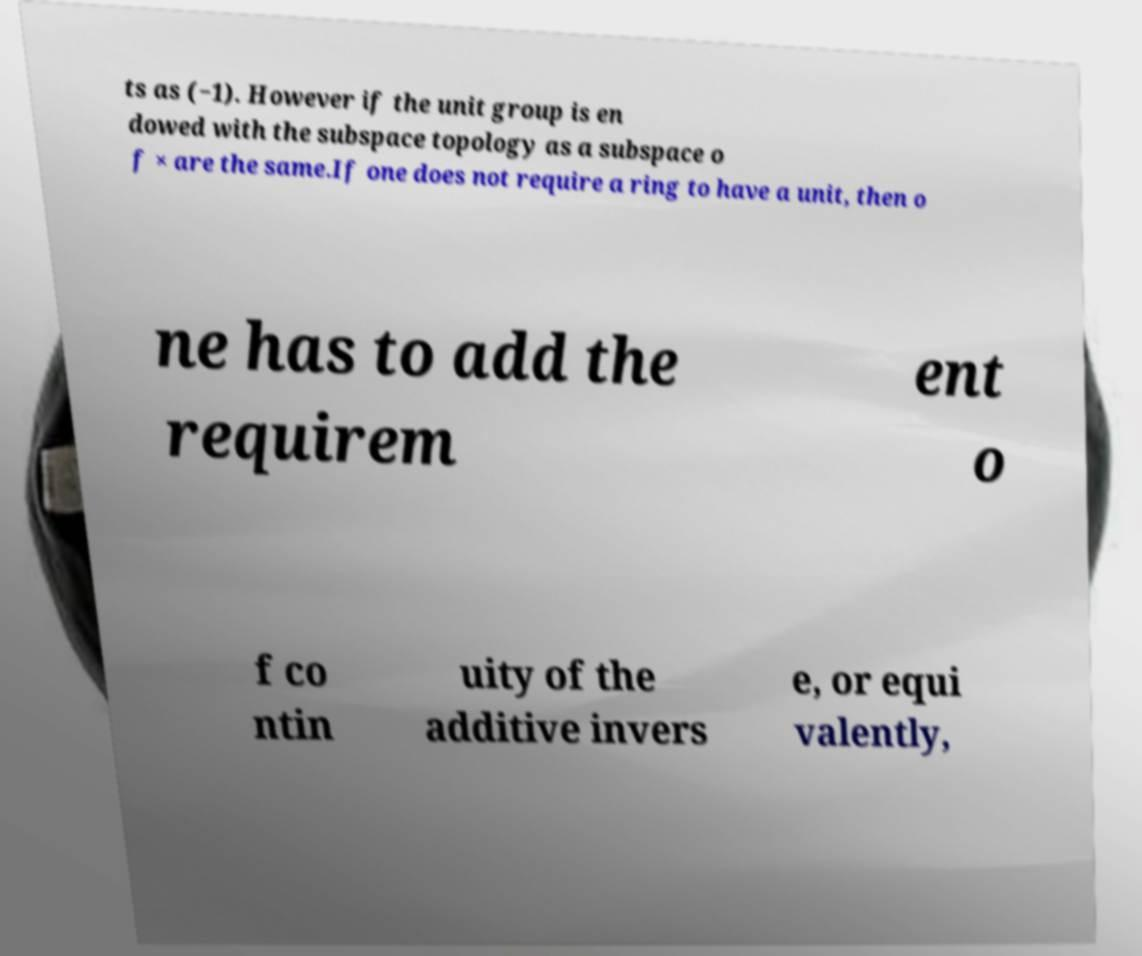For documentation purposes, I need the text within this image transcribed. Could you provide that? ts as (−1). However if the unit group is en dowed with the subspace topology as a subspace o f × are the same.If one does not require a ring to have a unit, then o ne has to add the requirem ent o f co ntin uity of the additive invers e, or equi valently, 